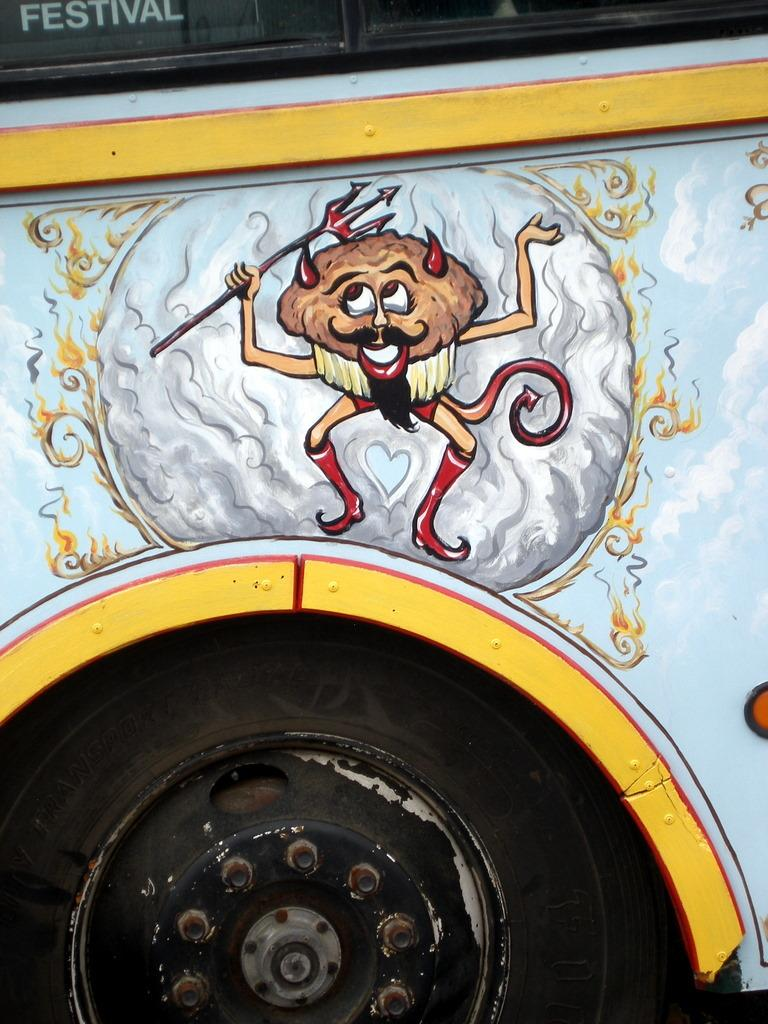What is the main subject of the image? There is a vehicle in the image. What is unique about the appearance of the vehicle? The vehicle has a painting of a person. What color is the wheel of the vehicle? The wheel of the vehicle is black in color. How many flowers are growing near the vehicle in the image? There are no flowers visible in the image; it only features a vehicle with a painting of a person and a black wheel. 